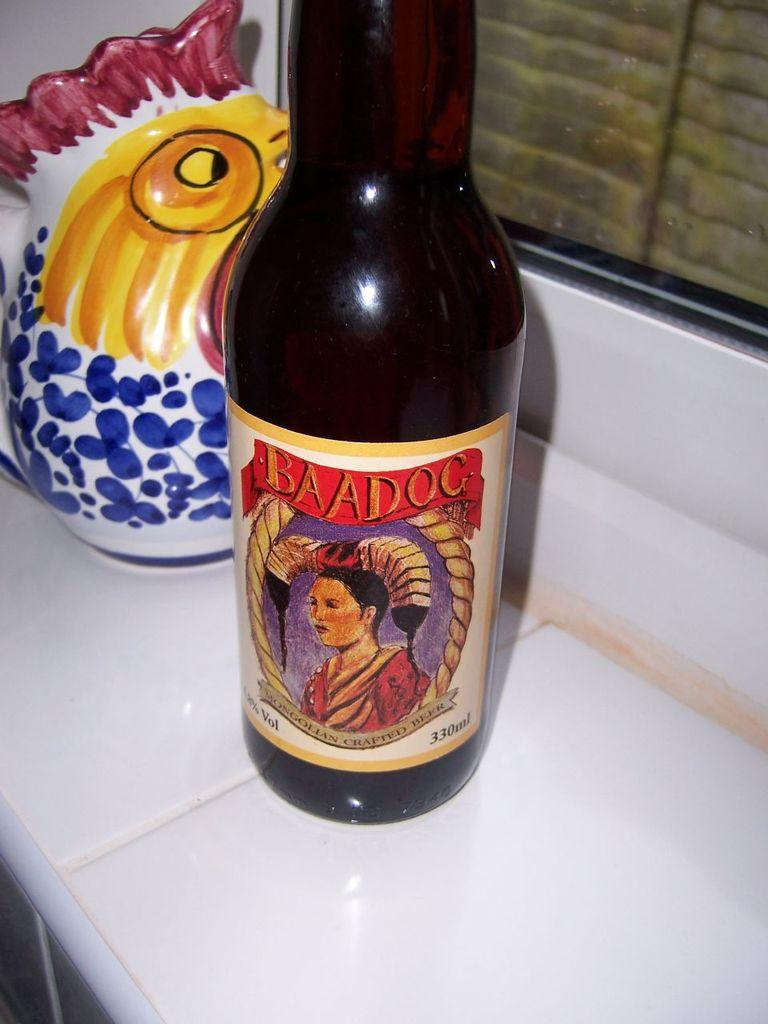<image>
Relay a brief, clear account of the picture shown. Bottle of BAADOC bear on a windowsill by a ceramic chicken. 